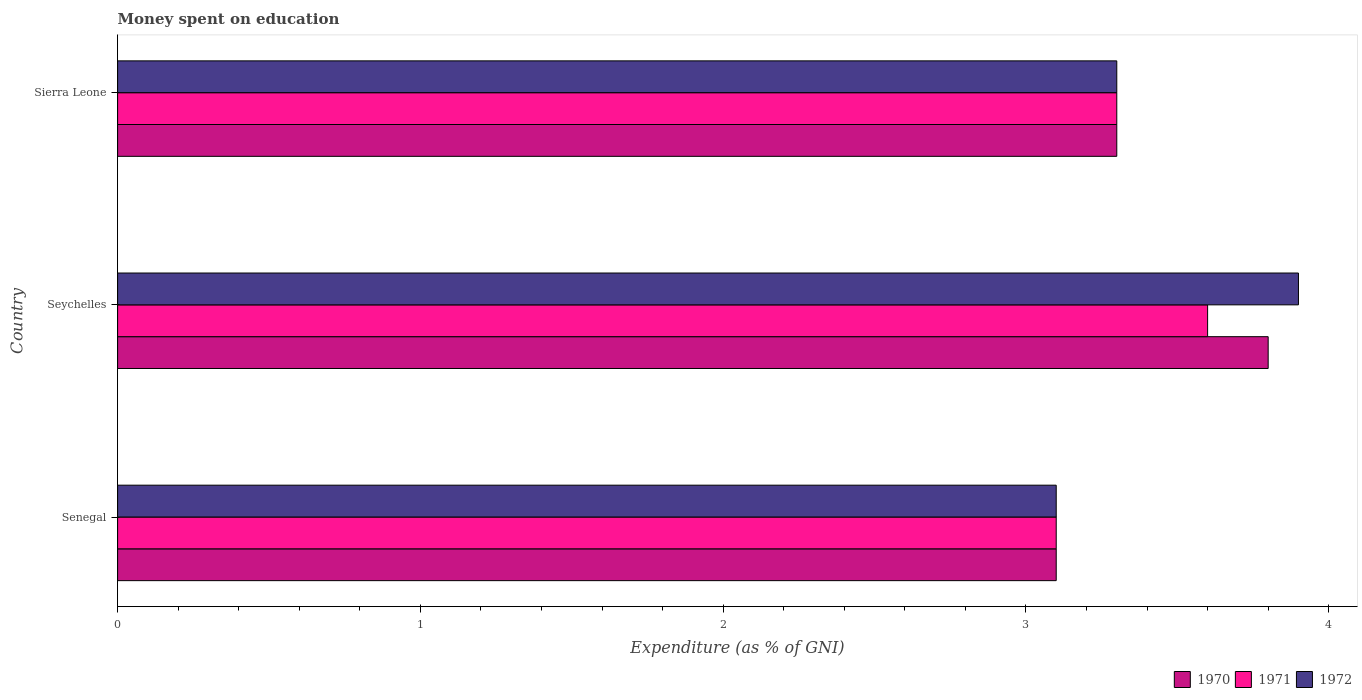How many different coloured bars are there?
Your answer should be compact. 3. How many groups of bars are there?
Your response must be concise. 3. Are the number of bars on each tick of the Y-axis equal?
Ensure brevity in your answer.  Yes. What is the label of the 3rd group of bars from the top?
Provide a short and direct response. Senegal. What is the amount of money spent on education in 1970 in Sierra Leone?
Your answer should be compact. 3.3. Across all countries, what is the maximum amount of money spent on education in 1970?
Provide a short and direct response. 3.8. In which country was the amount of money spent on education in 1970 maximum?
Your response must be concise. Seychelles. In which country was the amount of money spent on education in 1971 minimum?
Your response must be concise. Senegal. What is the total amount of money spent on education in 1971 in the graph?
Your response must be concise. 10. What is the difference between the amount of money spent on education in 1971 in Sierra Leone and the amount of money spent on education in 1972 in Seychelles?
Provide a short and direct response. -0.6. What is the average amount of money spent on education in 1970 per country?
Keep it short and to the point. 3.4. In how many countries, is the amount of money spent on education in 1971 greater than 2.8 %?
Offer a very short reply. 3. What is the ratio of the amount of money spent on education in 1970 in Senegal to that in Sierra Leone?
Your response must be concise. 0.94. Is the difference between the amount of money spent on education in 1971 in Seychelles and Sierra Leone greater than the difference between the amount of money spent on education in 1970 in Seychelles and Sierra Leone?
Make the answer very short. No. What is the difference between the highest and the lowest amount of money spent on education in 1971?
Keep it short and to the point. 0.5. What does the 2nd bar from the top in Sierra Leone represents?
Provide a short and direct response. 1971. Is it the case that in every country, the sum of the amount of money spent on education in 1970 and amount of money spent on education in 1971 is greater than the amount of money spent on education in 1972?
Give a very brief answer. Yes. How many bars are there?
Offer a terse response. 9. How many countries are there in the graph?
Provide a succinct answer. 3. Does the graph contain any zero values?
Provide a short and direct response. No. Does the graph contain grids?
Give a very brief answer. No. How many legend labels are there?
Provide a succinct answer. 3. What is the title of the graph?
Offer a very short reply. Money spent on education. What is the label or title of the X-axis?
Make the answer very short. Expenditure (as % of GNI). What is the label or title of the Y-axis?
Give a very brief answer. Country. What is the Expenditure (as % of GNI) of 1970 in Senegal?
Provide a short and direct response. 3.1. What is the Expenditure (as % of GNI) of 1971 in Senegal?
Your answer should be compact. 3.1. What is the Expenditure (as % of GNI) in 1971 in Seychelles?
Your response must be concise. 3.6. What is the Expenditure (as % of GNI) of 1970 in Sierra Leone?
Make the answer very short. 3.3. What is the Expenditure (as % of GNI) of 1971 in Sierra Leone?
Provide a succinct answer. 3.3. What is the Expenditure (as % of GNI) of 1972 in Sierra Leone?
Make the answer very short. 3.3. Across all countries, what is the maximum Expenditure (as % of GNI) in 1970?
Give a very brief answer. 3.8. Across all countries, what is the maximum Expenditure (as % of GNI) in 1971?
Ensure brevity in your answer.  3.6. Across all countries, what is the minimum Expenditure (as % of GNI) in 1971?
Ensure brevity in your answer.  3.1. What is the total Expenditure (as % of GNI) in 1970 in the graph?
Provide a succinct answer. 10.2. What is the total Expenditure (as % of GNI) of 1972 in the graph?
Make the answer very short. 10.3. What is the difference between the Expenditure (as % of GNI) of 1970 in Senegal and that in Seychelles?
Give a very brief answer. -0.7. What is the difference between the Expenditure (as % of GNI) of 1971 in Senegal and that in Seychelles?
Make the answer very short. -0.5. What is the difference between the Expenditure (as % of GNI) in 1972 in Senegal and that in Seychelles?
Your response must be concise. -0.8. What is the difference between the Expenditure (as % of GNI) of 1970 in Senegal and that in Sierra Leone?
Your response must be concise. -0.2. What is the difference between the Expenditure (as % of GNI) of 1972 in Senegal and that in Sierra Leone?
Give a very brief answer. -0.2. What is the difference between the Expenditure (as % of GNI) in 1972 in Seychelles and that in Sierra Leone?
Keep it short and to the point. 0.6. What is the difference between the Expenditure (as % of GNI) of 1970 in Senegal and the Expenditure (as % of GNI) of 1971 in Seychelles?
Provide a succinct answer. -0.5. What is the difference between the Expenditure (as % of GNI) in 1971 in Senegal and the Expenditure (as % of GNI) in 1972 in Seychelles?
Your answer should be very brief. -0.8. What is the difference between the Expenditure (as % of GNI) of 1971 in Senegal and the Expenditure (as % of GNI) of 1972 in Sierra Leone?
Give a very brief answer. -0.2. What is the average Expenditure (as % of GNI) in 1971 per country?
Keep it short and to the point. 3.33. What is the average Expenditure (as % of GNI) of 1972 per country?
Offer a terse response. 3.43. What is the difference between the Expenditure (as % of GNI) in 1970 and Expenditure (as % of GNI) in 1972 in Senegal?
Give a very brief answer. 0. What is the difference between the Expenditure (as % of GNI) of 1971 and Expenditure (as % of GNI) of 1972 in Senegal?
Provide a short and direct response. 0. What is the difference between the Expenditure (as % of GNI) in 1971 and Expenditure (as % of GNI) in 1972 in Seychelles?
Give a very brief answer. -0.3. What is the difference between the Expenditure (as % of GNI) in 1970 and Expenditure (as % of GNI) in 1971 in Sierra Leone?
Your answer should be very brief. 0. What is the difference between the Expenditure (as % of GNI) of 1970 and Expenditure (as % of GNI) of 1972 in Sierra Leone?
Offer a terse response. 0. What is the ratio of the Expenditure (as % of GNI) of 1970 in Senegal to that in Seychelles?
Provide a succinct answer. 0.82. What is the ratio of the Expenditure (as % of GNI) in 1971 in Senegal to that in Seychelles?
Offer a very short reply. 0.86. What is the ratio of the Expenditure (as % of GNI) in 1972 in Senegal to that in Seychelles?
Your answer should be very brief. 0.79. What is the ratio of the Expenditure (as % of GNI) of 1970 in Senegal to that in Sierra Leone?
Provide a succinct answer. 0.94. What is the ratio of the Expenditure (as % of GNI) of 1971 in Senegal to that in Sierra Leone?
Provide a short and direct response. 0.94. What is the ratio of the Expenditure (as % of GNI) in 1972 in Senegal to that in Sierra Leone?
Give a very brief answer. 0.94. What is the ratio of the Expenditure (as % of GNI) of 1970 in Seychelles to that in Sierra Leone?
Make the answer very short. 1.15. What is the ratio of the Expenditure (as % of GNI) in 1971 in Seychelles to that in Sierra Leone?
Your answer should be compact. 1.09. What is the ratio of the Expenditure (as % of GNI) of 1972 in Seychelles to that in Sierra Leone?
Your answer should be very brief. 1.18. What is the difference between the highest and the second highest Expenditure (as % of GNI) in 1971?
Keep it short and to the point. 0.3. What is the difference between the highest and the second highest Expenditure (as % of GNI) in 1972?
Your answer should be very brief. 0.6. What is the difference between the highest and the lowest Expenditure (as % of GNI) in 1970?
Give a very brief answer. 0.7. What is the difference between the highest and the lowest Expenditure (as % of GNI) of 1971?
Provide a short and direct response. 0.5. 